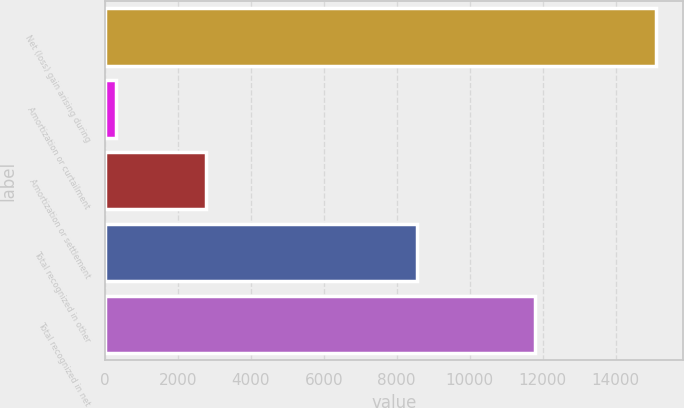Convert chart to OTSL. <chart><loc_0><loc_0><loc_500><loc_500><bar_chart><fcel>Net (loss) gain arising during<fcel>Amortization or curtailment<fcel>Amortization or settlement<fcel>Total recognized in other<fcel>Total recognized in net<nl><fcel>15098<fcel>313<fcel>2768<fcel>8557<fcel>11777<nl></chart> 